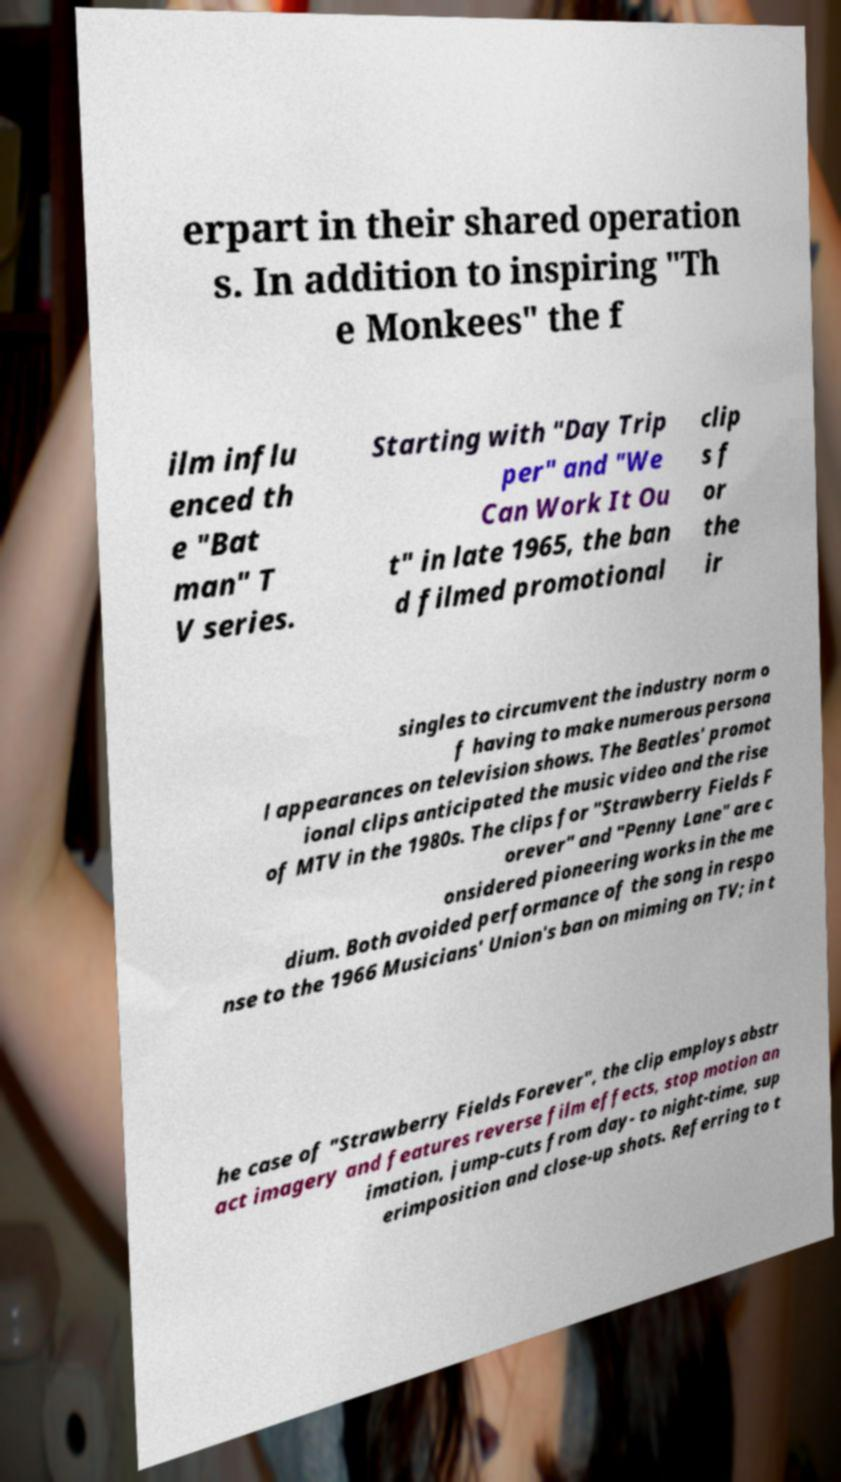What messages or text are displayed in this image? I need them in a readable, typed format. erpart in their shared operation s. In addition to inspiring "Th e Monkees" the f ilm influ enced th e "Bat man" T V series. Starting with "Day Trip per" and "We Can Work It Ou t" in late 1965, the ban d filmed promotional clip s f or the ir singles to circumvent the industry norm o f having to make numerous persona l appearances on television shows. The Beatles' promot ional clips anticipated the music video and the rise of MTV in the 1980s. The clips for "Strawberry Fields F orever" and "Penny Lane" are c onsidered pioneering works in the me dium. Both avoided performance of the song in respo nse to the 1966 Musicians' Union's ban on miming on TV; in t he case of "Strawberry Fields Forever", the clip employs abstr act imagery and features reverse film effects, stop motion an imation, jump-cuts from day- to night-time, sup erimposition and close-up shots. Referring to t 